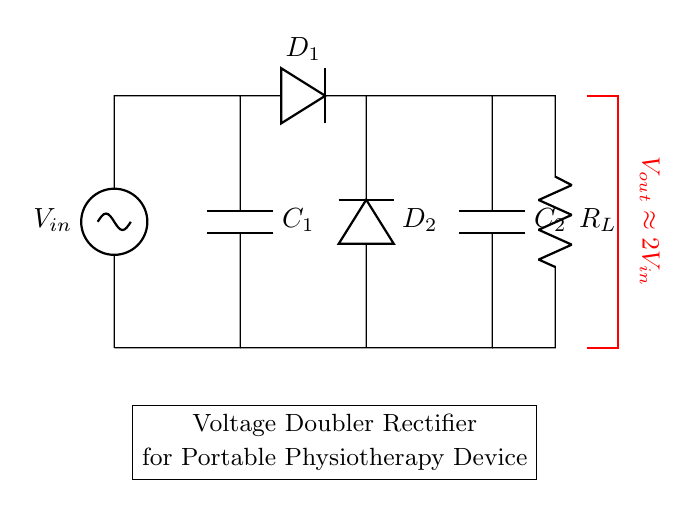What is the input voltage in the circuit? The input voltage is labeled as V_in in the circuit diagram.
Answer: V_in What are the components used in this rectifier circuit? The main components are two diodes (D1 and D2), two capacitors (C1 and C2), and a load resistor (R_L).
Answer: Diodes, capacitors, load resistor What is the approximate output voltage of this voltage doubler? The output voltage is approximately double the input voltage, as indicated in the diagram.
Answer: 2V_in How many capacitors are present in the circuit? There are two capacitors, C1 and C2, used for voltage doubling and smoothing the output voltage.
Answer: 2 What role do the diodes play in this circuit? The diodes D1 and D2 direct the flow of current in one direction, facilitating the voltage doubling process by allowing capacitors to charge in the correct sequence.
Answer: Current direction Why is this circuit called a voltage doubler? The circuit uses capacitors and diodes in such a configuration that it effectively doubles the input voltage to give an output of approximately 2V_in.
Answer: Voltage doubling 